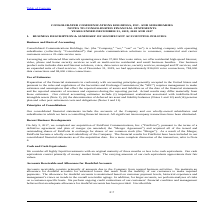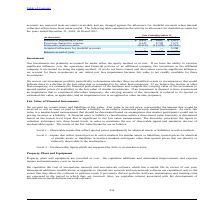According to Consolidated Communications Holdings's financial document, What does the accounts receivable consist of? consists primarily of amounts due to the Company from normal business activities.. The document states: "Accounts receivable consists primarily of amounts due to the Company from normal business activities. We maintain an allowance for doubtful accounts f..." Also, What was the provision charged to expense in 2019? According to the financial document, 9,347 (in thousands). The relevant text states: "Provision charged to expense 9,347 8,793 7,072..." Also, What was the Balance at beginning of year in 2019? According to the financial document, $4,421 (in thousands). The relevant text states: "Balance at beginning of year $ 4,421 $ 6,667 $ 2,813..." Also, can you calculate: What was the increase / (decrease) in the balance at beginning of year from 2018 to 2019? Based on the calculation: 4,421 - 6,667, the result is -2246 (in thousands). This is based on the information: "Balance at beginning of year $ 4,421 $ 6,667 $ 2,813 Balance at beginning of year $ 4,421 $ 6,667 $ 2,813..." The key data points involved are: 4,421, 6,667. Also, can you calculate: What was the average provision charged to expense for 2017-2019? To answer this question, I need to perform calculations using the financial data. The calculation is: (9,347 + 8,793 + 7,072) / 3, which equals 8404 (in thousands). This is based on the information: "Provision charged to expense 9,347 8,793 7,072 Provision charged to expense 9,347 8,793 7,072 Provision charged to expense 9,347 8,793 7,072..." The key data points involved are: 7,072, 8,793, 9,347. Also, can you calculate: What was the increase / (decrease) in the Acquired allowance for doubtful accounts from 2017 to 2018? Based on the calculation: 0 - 3,298, the result is -3298 (in thousands). This is based on the information: "(In thousands) 2019 2018 2017 Acquired allowance for doubtful accounts — — 3,298..." The key data points involved are: 0, 3,298. 